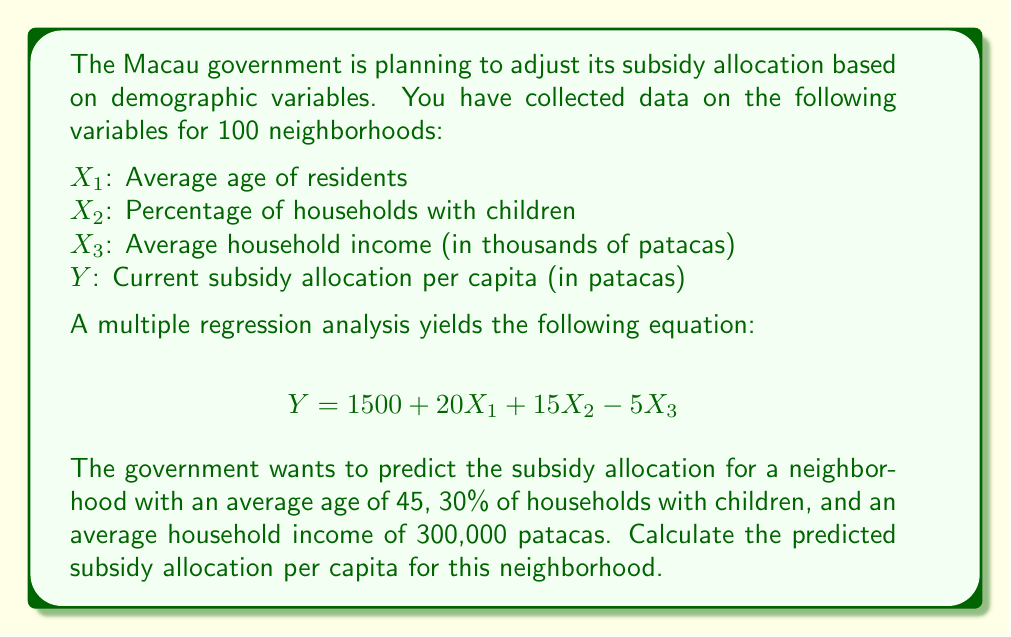Solve this math problem. To solve this problem, we need to use the given multiple regression equation and substitute the values for each independent variable. Let's break it down step-by-step:

1. The multiple regression equation is:
   $$Y = 1500 + 20X_1 + 15X_2 - 5X_3$$

2. We are given the following values:
   $X_1$ (Average age) = 45
   $X_2$ (Percentage of households with children) = 30
   $X_3$ (Average household income in thousands) = 300

3. Let's substitute these values into the equation:
   $$Y = 1500 + 20(45) + 15(30) - 5(300)$$

4. Now, let's calculate each term:
   - $20(45) = 900$
   - $15(30) = 450$
   - $5(300) = 1500$

5. Substituting these calculated values:
   $$Y = 1500 + 900 + 450 - 1500$$

6. Finally, let's sum up all the terms:
   $$Y = 1500 + 900 + 450 - 1500 = 1350$$

Therefore, the predicted subsidy allocation per capita for this neighborhood is 1350 patacas.
Answer: 1350 patacas 